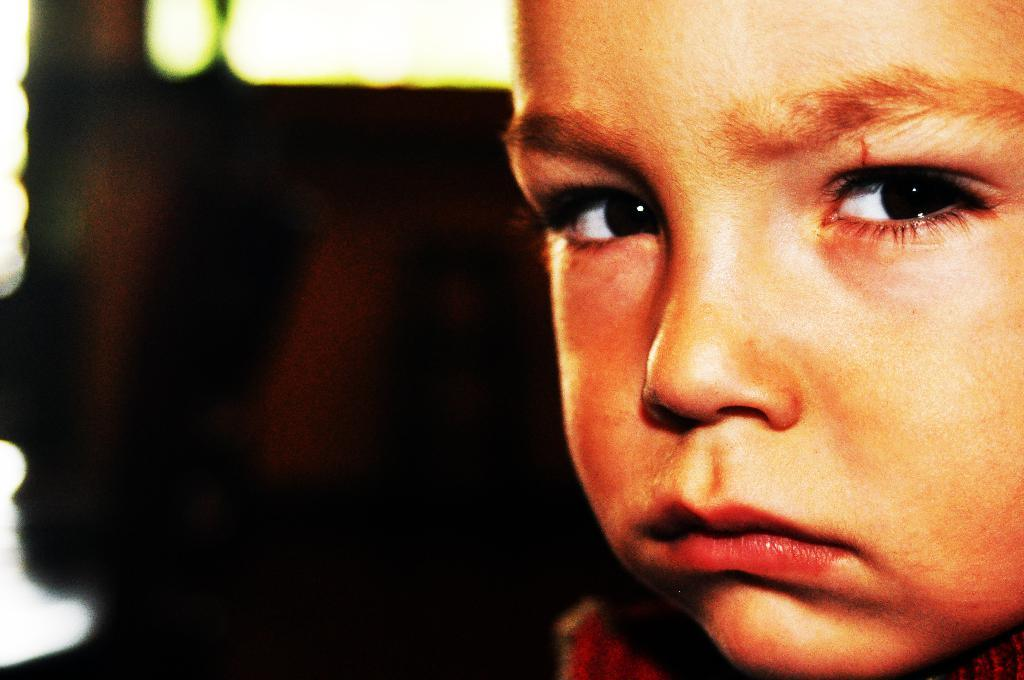Who is the main subject in the picture? There is a boy in the picture. What direction is the boy looking in? The boy is looking towards the right. Can you describe any background elements in the picture? There might be a door in the background of the picture. What is the nature of the image on the left side of the picture? There is a blurred image on the left side of the picture. What type of volcano can be seen erupting in the background of the picture? There is no volcano present in the image; it features a boy looking towards the right with a blurred image on the left side. Can you tell me how many turkeys are visible in the picture? There are no turkeys present in the image. 